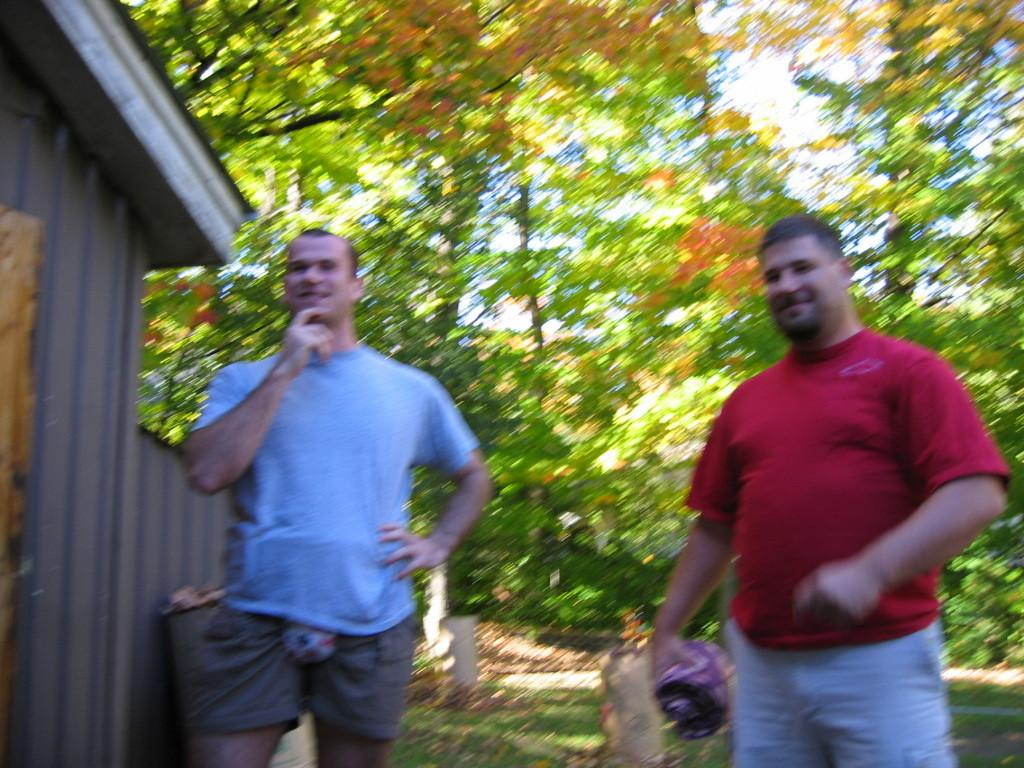How many people are in the image? There are two persons standing in the center of the image. What can be seen in the background of the image? There are trees in the background of the image. What structure is located on the left side of the image? There is a house on the left side of the image. What type of ground is visible at the bottom of the image? There is grass visible at the bottom of the image. What type of muscle can be seen flexing in the image? There is no muscle visible in the image; it features two persons standing and a background with trees and a house. 